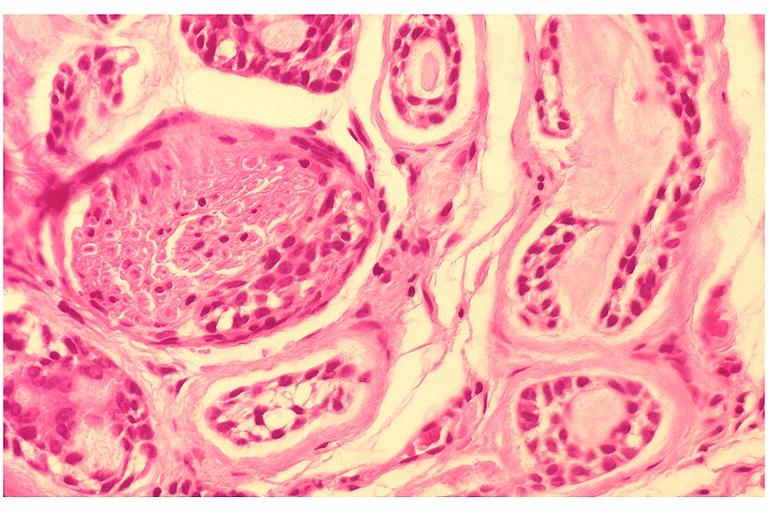s oral present?
Answer the question using a single word or phrase. Yes 